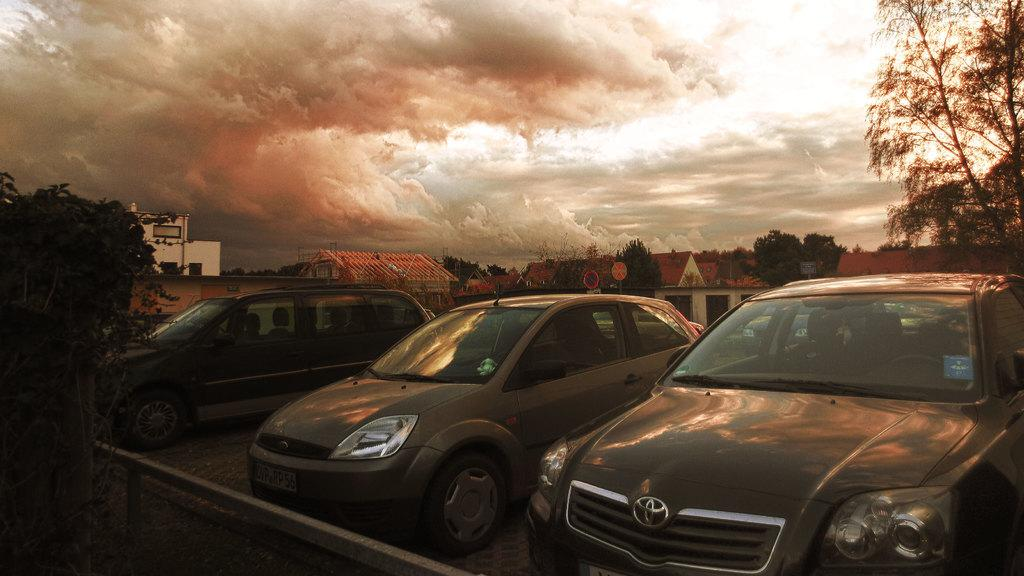What is placed on the footpath in the image? There are cars placed on the footpath in the image. What type of vegetation can be seen in the image? There are trees visible in the image. What type of structures are present in the image? There are houses with roofs in the image. What type of signage is present in the image? Sign boards are present in the image. What type of vertical structure is present in the image? There is a pole in the image. What is the condition of the sky in the image? The sky is visible in the image and appears cloudy. What type of net can be seen in the image? There is no net present in the image. 